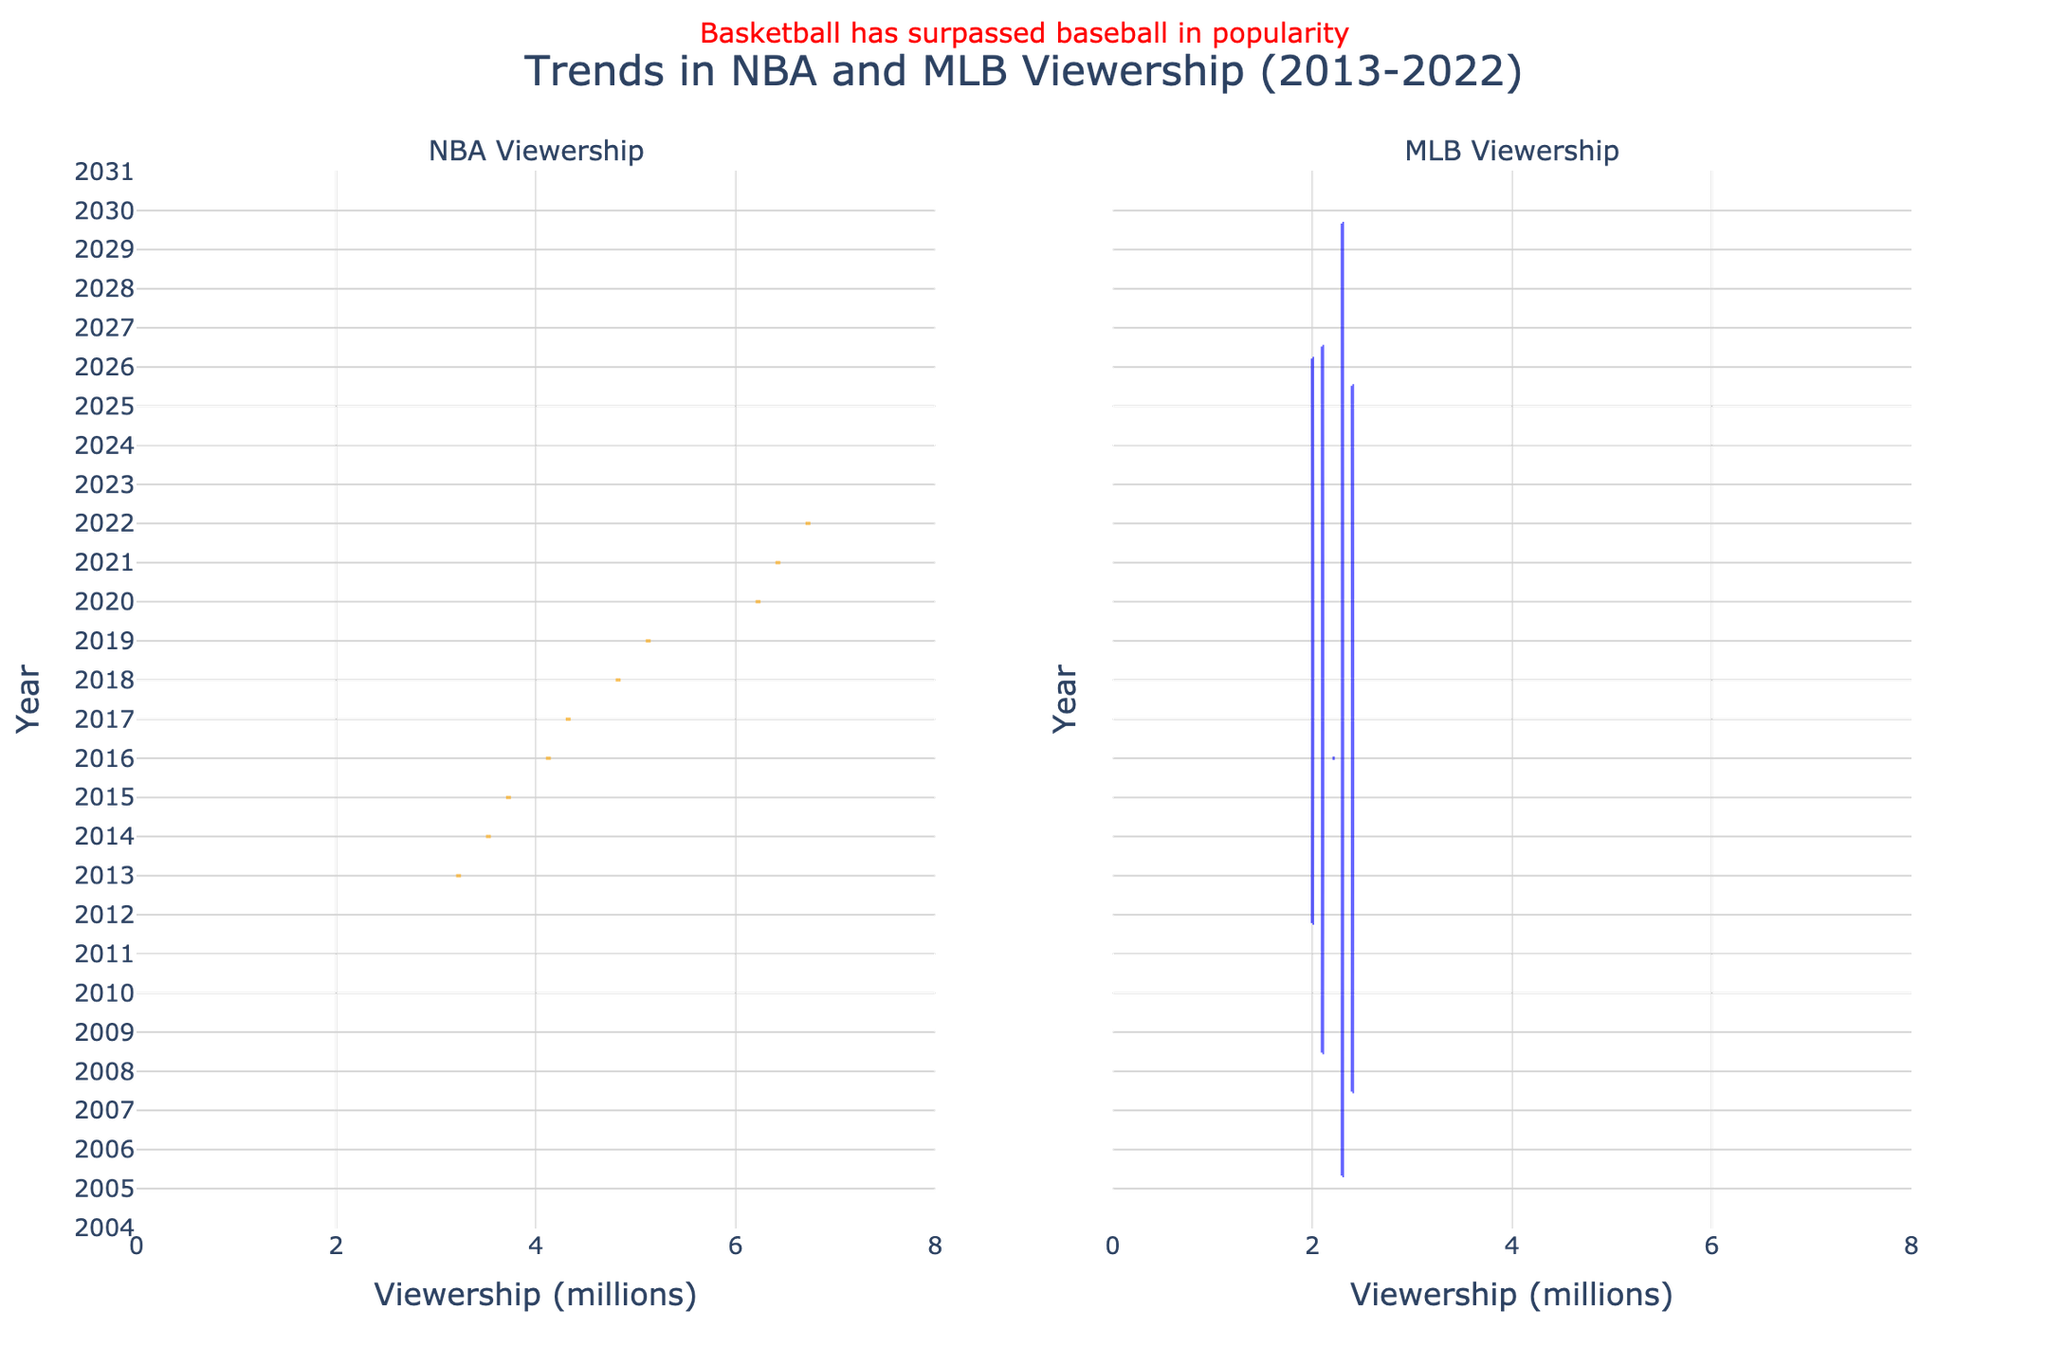What is the title of the chart? The title of the chart is located at the top center part of the figure and usually gives an overall description of what the chart is about.
Answer: Trends in NBA and MLB Viewership (2013-2022) What is the range of viewership values for NBA games? By observing the horizontal axis for the NBA viewership on the left side of the chart, we can see the spread of the data.
Answer: 3.2 to 6.7 million How do the viewership values of MLB games in 2018 compare to those in 2021? Look at the positions of the 2018 and 2021 marks on the horizontal axis for MLB viewership. Notice which value is higher or lower.
Answer: Both years are around 2.3 million What can you say about the general trend of NBA viewership over the years? By examining the violin plot on the left side, we can see how the data points are distributed year by year for the NBA. The plot shows a clear increase in median viewership over the decade.
Answer: Increasing trend Which year had the highest viewership for NBA games? Identify the peak point in the NBA violin plot on the horizontal axis on the left side of the chart. Notice which year corresponds to the highest value.
Answer: 2022 How does the median NBA viewership compare with the median MLB viewership in 2020? To find the median, look for the thickest part of the violin plot for both NBA and MLB in 2020. Compare these values.
Answer: NBA median is higher than MLB median Compare the spread of viewership for NBA and MLB games in 2016. Which one has a wider range? Look at the width of the violin plots for NBA and MLB in 2016 along the horizontal axis. The wider the violin plot, the greater the spread.
Answer: NBA has a wider range Which league shows more consistency in viewership over the years when looking at the violin plots? Consistency can be observed through the width and uniformity of the violin plots over the years. The narrower and more uniform the plots, the higher the consistency.
Answer: MLB shows more consistency How do the overall shapes of the NBA and MLB violin plots over the decade compare? Compare the distributions along the horizontal axis of both violin plots in terms of shape and spread. Note the overall trends and data spread.
Answer: NBA is more positively skewed What annotation is present on the chart and what does it indicate? The annotation is generally a textual note on the chart providing additional insights or comments about the data.
Answer: "Basketball has surpassed baseball in popularity" 